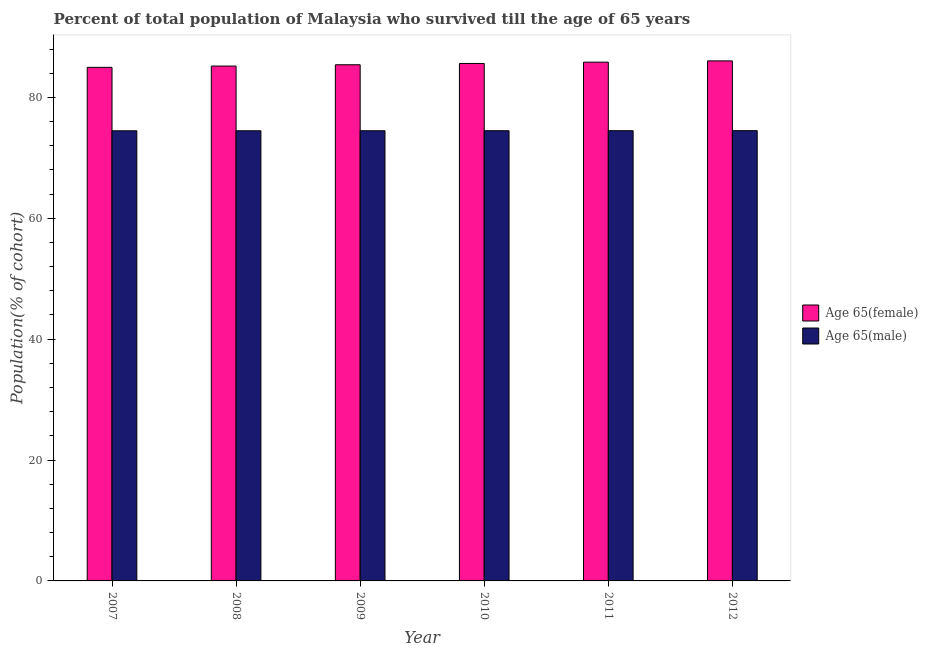How many different coloured bars are there?
Provide a succinct answer. 2. How many groups of bars are there?
Your response must be concise. 6. Are the number of bars on each tick of the X-axis equal?
Keep it short and to the point. Yes. In how many cases, is the number of bars for a given year not equal to the number of legend labels?
Offer a terse response. 0. What is the percentage of female population who survived till age of 65 in 2011?
Provide a short and direct response. 85.83. Across all years, what is the maximum percentage of male population who survived till age of 65?
Keep it short and to the point. 74.49. Across all years, what is the minimum percentage of male population who survived till age of 65?
Your response must be concise. 74.48. In which year was the percentage of female population who survived till age of 65 maximum?
Your response must be concise. 2012. In which year was the percentage of female population who survived till age of 65 minimum?
Offer a terse response. 2007. What is the total percentage of male population who survived till age of 65 in the graph?
Offer a very short reply. 446.91. What is the difference between the percentage of female population who survived till age of 65 in 2010 and that in 2011?
Your response must be concise. -0.21. What is the difference between the percentage of male population who survived till age of 65 in 2012 and the percentage of female population who survived till age of 65 in 2007?
Keep it short and to the point. 0.02. What is the average percentage of male population who survived till age of 65 per year?
Your response must be concise. 74.48. In how many years, is the percentage of female population who survived till age of 65 greater than 80 %?
Offer a very short reply. 6. What is the ratio of the percentage of male population who survived till age of 65 in 2010 to that in 2011?
Make the answer very short. 1. Is the difference between the percentage of male population who survived till age of 65 in 2008 and 2011 greater than the difference between the percentage of female population who survived till age of 65 in 2008 and 2011?
Ensure brevity in your answer.  No. What is the difference between the highest and the second highest percentage of male population who survived till age of 65?
Make the answer very short. 0. What is the difference between the highest and the lowest percentage of female population who survived till age of 65?
Make the answer very short. 1.07. In how many years, is the percentage of male population who survived till age of 65 greater than the average percentage of male population who survived till age of 65 taken over all years?
Provide a short and direct response. 3. Is the sum of the percentage of female population who survived till age of 65 in 2008 and 2012 greater than the maximum percentage of male population who survived till age of 65 across all years?
Your answer should be very brief. Yes. What does the 2nd bar from the left in 2008 represents?
Your answer should be compact. Age 65(male). What does the 1st bar from the right in 2012 represents?
Provide a succinct answer. Age 65(male). How many bars are there?
Give a very brief answer. 12. Are all the bars in the graph horizontal?
Your answer should be compact. No. How many years are there in the graph?
Provide a succinct answer. 6. Are the values on the major ticks of Y-axis written in scientific E-notation?
Offer a terse response. No. Does the graph contain any zero values?
Offer a terse response. No. Where does the legend appear in the graph?
Provide a short and direct response. Center right. How are the legend labels stacked?
Ensure brevity in your answer.  Vertical. What is the title of the graph?
Give a very brief answer. Percent of total population of Malaysia who survived till the age of 65 years. Does "Technicians" appear as one of the legend labels in the graph?
Offer a terse response. No. What is the label or title of the Y-axis?
Provide a succinct answer. Population(% of cohort). What is the Population(% of cohort) of Age 65(female) in 2007?
Provide a short and direct response. 84.97. What is the Population(% of cohort) of Age 65(male) in 2007?
Provide a succinct answer. 74.48. What is the Population(% of cohort) of Age 65(female) in 2008?
Ensure brevity in your answer.  85.18. What is the Population(% of cohort) of Age 65(male) in 2008?
Give a very brief answer. 74.48. What is the Population(% of cohort) in Age 65(female) in 2009?
Provide a succinct answer. 85.4. What is the Population(% of cohort) of Age 65(male) in 2009?
Your answer should be compact. 74.48. What is the Population(% of cohort) of Age 65(female) in 2010?
Your response must be concise. 85.61. What is the Population(% of cohort) of Age 65(male) in 2010?
Your answer should be very brief. 74.49. What is the Population(% of cohort) in Age 65(female) in 2011?
Keep it short and to the point. 85.83. What is the Population(% of cohort) in Age 65(male) in 2011?
Give a very brief answer. 74.49. What is the Population(% of cohort) in Age 65(female) in 2012?
Your answer should be very brief. 86.04. What is the Population(% of cohort) of Age 65(male) in 2012?
Your response must be concise. 74.49. Across all years, what is the maximum Population(% of cohort) in Age 65(female)?
Keep it short and to the point. 86.04. Across all years, what is the maximum Population(% of cohort) in Age 65(male)?
Give a very brief answer. 74.49. Across all years, what is the minimum Population(% of cohort) in Age 65(female)?
Provide a succinct answer. 84.97. Across all years, what is the minimum Population(% of cohort) in Age 65(male)?
Make the answer very short. 74.48. What is the total Population(% of cohort) in Age 65(female) in the graph?
Provide a succinct answer. 513.04. What is the total Population(% of cohort) in Age 65(male) in the graph?
Your answer should be compact. 446.91. What is the difference between the Population(% of cohort) in Age 65(female) in 2007 and that in 2008?
Your answer should be very brief. -0.21. What is the difference between the Population(% of cohort) of Age 65(male) in 2007 and that in 2008?
Ensure brevity in your answer.  -0. What is the difference between the Population(% of cohort) of Age 65(female) in 2007 and that in 2009?
Give a very brief answer. -0.43. What is the difference between the Population(% of cohort) of Age 65(male) in 2007 and that in 2009?
Your response must be concise. -0.01. What is the difference between the Population(% of cohort) of Age 65(female) in 2007 and that in 2010?
Ensure brevity in your answer.  -0.64. What is the difference between the Population(% of cohort) of Age 65(male) in 2007 and that in 2010?
Give a very brief answer. -0.01. What is the difference between the Population(% of cohort) of Age 65(female) in 2007 and that in 2011?
Offer a terse response. -0.86. What is the difference between the Population(% of cohort) of Age 65(male) in 2007 and that in 2011?
Offer a terse response. -0.02. What is the difference between the Population(% of cohort) in Age 65(female) in 2007 and that in 2012?
Ensure brevity in your answer.  -1.07. What is the difference between the Population(% of cohort) of Age 65(male) in 2007 and that in 2012?
Your answer should be compact. -0.02. What is the difference between the Population(% of cohort) in Age 65(female) in 2008 and that in 2009?
Your answer should be very brief. -0.21. What is the difference between the Population(% of cohort) of Age 65(male) in 2008 and that in 2009?
Provide a succinct answer. -0. What is the difference between the Population(% of cohort) in Age 65(female) in 2008 and that in 2010?
Make the answer very short. -0.43. What is the difference between the Population(% of cohort) of Age 65(male) in 2008 and that in 2010?
Make the answer very short. -0.01. What is the difference between the Population(% of cohort) of Age 65(female) in 2008 and that in 2011?
Give a very brief answer. -0.64. What is the difference between the Population(% of cohort) in Age 65(male) in 2008 and that in 2011?
Give a very brief answer. -0.01. What is the difference between the Population(% of cohort) in Age 65(female) in 2008 and that in 2012?
Ensure brevity in your answer.  -0.86. What is the difference between the Population(% of cohort) of Age 65(male) in 2008 and that in 2012?
Give a very brief answer. -0.02. What is the difference between the Population(% of cohort) of Age 65(female) in 2009 and that in 2010?
Give a very brief answer. -0.21. What is the difference between the Population(% of cohort) of Age 65(male) in 2009 and that in 2010?
Provide a succinct answer. -0. What is the difference between the Population(% of cohort) in Age 65(female) in 2009 and that in 2011?
Provide a short and direct response. -0.43. What is the difference between the Population(% of cohort) of Age 65(male) in 2009 and that in 2011?
Make the answer very short. -0.01. What is the difference between the Population(% of cohort) of Age 65(female) in 2009 and that in 2012?
Your response must be concise. -0.64. What is the difference between the Population(% of cohort) of Age 65(male) in 2009 and that in 2012?
Your response must be concise. -0.01. What is the difference between the Population(% of cohort) in Age 65(female) in 2010 and that in 2011?
Make the answer very short. -0.21. What is the difference between the Population(% of cohort) of Age 65(male) in 2010 and that in 2011?
Your answer should be very brief. -0. What is the difference between the Population(% of cohort) of Age 65(female) in 2010 and that in 2012?
Provide a short and direct response. -0.43. What is the difference between the Population(% of cohort) of Age 65(male) in 2010 and that in 2012?
Your response must be concise. -0.01. What is the difference between the Population(% of cohort) in Age 65(female) in 2011 and that in 2012?
Your answer should be compact. -0.21. What is the difference between the Population(% of cohort) in Age 65(male) in 2011 and that in 2012?
Your response must be concise. -0. What is the difference between the Population(% of cohort) of Age 65(female) in 2007 and the Population(% of cohort) of Age 65(male) in 2008?
Make the answer very short. 10.49. What is the difference between the Population(% of cohort) in Age 65(female) in 2007 and the Population(% of cohort) in Age 65(male) in 2009?
Your answer should be very brief. 10.49. What is the difference between the Population(% of cohort) in Age 65(female) in 2007 and the Population(% of cohort) in Age 65(male) in 2010?
Give a very brief answer. 10.48. What is the difference between the Population(% of cohort) in Age 65(female) in 2007 and the Population(% of cohort) in Age 65(male) in 2011?
Offer a terse response. 10.48. What is the difference between the Population(% of cohort) in Age 65(female) in 2007 and the Population(% of cohort) in Age 65(male) in 2012?
Your response must be concise. 10.48. What is the difference between the Population(% of cohort) in Age 65(female) in 2008 and the Population(% of cohort) in Age 65(male) in 2009?
Make the answer very short. 10.7. What is the difference between the Population(% of cohort) in Age 65(female) in 2008 and the Population(% of cohort) in Age 65(male) in 2010?
Offer a terse response. 10.7. What is the difference between the Population(% of cohort) of Age 65(female) in 2008 and the Population(% of cohort) of Age 65(male) in 2011?
Offer a terse response. 10.69. What is the difference between the Population(% of cohort) of Age 65(female) in 2008 and the Population(% of cohort) of Age 65(male) in 2012?
Make the answer very short. 10.69. What is the difference between the Population(% of cohort) of Age 65(female) in 2009 and the Population(% of cohort) of Age 65(male) in 2010?
Your answer should be compact. 10.91. What is the difference between the Population(% of cohort) in Age 65(female) in 2009 and the Population(% of cohort) in Age 65(male) in 2011?
Make the answer very short. 10.91. What is the difference between the Population(% of cohort) of Age 65(female) in 2009 and the Population(% of cohort) of Age 65(male) in 2012?
Provide a succinct answer. 10.9. What is the difference between the Population(% of cohort) of Age 65(female) in 2010 and the Population(% of cohort) of Age 65(male) in 2011?
Your answer should be very brief. 11.12. What is the difference between the Population(% of cohort) of Age 65(female) in 2010 and the Population(% of cohort) of Age 65(male) in 2012?
Your answer should be compact. 11.12. What is the difference between the Population(% of cohort) in Age 65(female) in 2011 and the Population(% of cohort) in Age 65(male) in 2012?
Provide a short and direct response. 11.33. What is the average Population(% of cohort) of Age 65(female) per year?
Provide a short and direct response. 85.51. What is the average Population(% of cohort) in Age 65(male) per year?
Your answer should be compact. 74.48. In the year 2007, what is the difference between the Population(% of cohort) in Age 65(female) and Population(% of cohort) in Age 65(male)?
Your answer should be compact. 10.5. In the year 2008, what is the difference between the Population(% of cohort) of Age 65(female) and Population(% of cohort) of Age 65(male)?
Make the answer very short. 10.71. In the year 2009, what is the difference between the Population(% of cohort) of Age 65(female) and Population(% of cohort) of Age 65(male)?
Keep it short and to the point. 10.92. In the year 2010, what is the difference between the Population(% of cohort) of Age 65(female) and Population(% of cohort) of Age 65(male)?
Offer a very short reply. 11.13. In the year 2011, what is the difference between the Population(% of cohort) in Age 65(female) and Population(% of cohort) in Age 65(male)?
Offer a terse response. 11.34. In the year 2012, what is the difference between the Population(% of cohort) in Age 65(female) and Population(% of cohort) in Age 65(male)?
Keep it short and to the point. 11.55. What is the ratio of the Population(% of cohort) in Age 65(male) in 2007 to that in 2008?
Your response must be concise. 1. What is the ratio of the Population(% of cohort) of Age 65(male) in 2007 to that in 2009?
Make the answer very short. 1. What is the ratio of the Population(% of cohort) in Age 65(male) in 2007 to that in 2010?
Your answer should be very brief. 1. What is the ratio of the Population(% of cohort) in Age 65(male) in 2007 to that in 2011?
Offer a terse response. 1. What is the ratio of the Population(% of cohort) of Age 65(female) in 2007 to that in 2012?
Your answer should be compact. 0.99. What is the ratio of the Population(% of cohort) of Age 65(male) in 2008 to that in 2009?
Your answer should be compact. 1. What is the ratio of the Population(% of cohort) in Age 65(male) in 2008 to that in 2011?
Your answer should be compact. 1. What is the ratio of the Population(% of cohort) of Age 65(male) in 2008 to that in 2012?
Give a very brief answer. 1. What is the ratio of the Population(% of cohort) in Age 65(female) in 2009 to that in 2010?
Provide a succinct answer. 1. What is the ratio of the Population(% of cohort) of Age 65(male) in 2009 to that in 2010?
Provide a succinct answer. 1. What is the ratio of the Population(% of cohort) in Age 65(male) in 2009 to that in 2011?
Offer a very short reply. 1. What is the ratio of the Population(% of cohort) in Age 65(female) in 2010 to that in 2011?
Provide a short and direct response. 1. What is the ratio of the Population(% of cohort) in Age 65(male) in 2010 to that in 2012?
Keep it short and to the point. 1. What is the difference between the highest and the second highest Population(% of cohort) in Age 65(female)?
Provide a succinct answer. 0.21. What is the difference between the highest and the second highest Population(% of cohort) in Age 65(male)?
Keep it short and to the point. 0. What is the difference between the highest and the lowest Population(% of cohort) of Age 65(female)?
Keep it short and to the point. 1.07. What is the difference between the highest and the lowest Population(% of cohort) of Age 65(male)?
Keep it short and to the point. 0.02. 